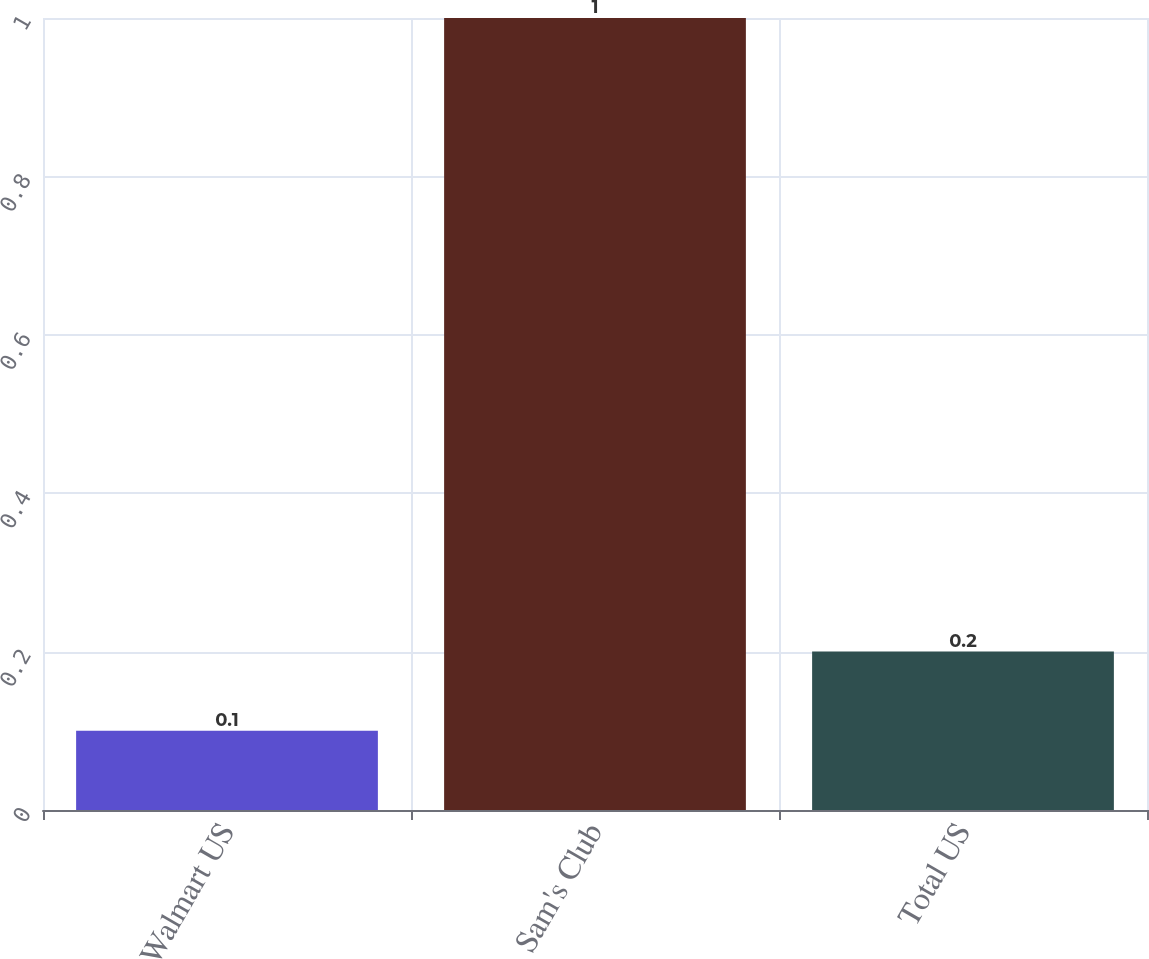<chart> <loc_0><loc_0><loc_500><loc_500><bar_chart><fcel>Walmart US<fcel>Sam's Club<fcel>Total US<nl><fcel>0.1<fcel>1<fcel>0.2<nl></chart> 